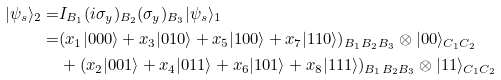<formula> <loc_0><loc_0><loc_500><loc_500>| \psi _ { s } \rangle _ { 2 } = & I _ { B _ { 1 } } ( i \sigma _ { y } ) _ { B _ { 2 } } ( \sigma _ { y } ) _ { B _ { 3 } } | \psi _ { s } \rangle _ { 1 } \\ = & ( x _ { 1 } | 0 0 0 \rangle + x _ { 3 } | 0 1 0 \rangle + x _ { 5 } | 1 0 0 \rangle + x _ { 7 } | 1 1 0 \rangle ) _ { B _ { 1 } B _ { 2 } B _ { 3 } } \otimes | 0 0 \rangle _ { C _ { 1 } C _ { 2 } } \\ & + ( x _ { 2 } | 0 0 1 \rangle + x _ { 4 } | 0 1 1 \rangle + x _ { 6 } | 1 0 1 \rangle + x _ { 8 } | 1 1 1 \rangle ) _ { B _ { 1 } B _ { 2 } B _ { 3 } } \otimes | 1 1 \rangle _ { C _ { 1 } C _ { 2 } }</formula> 